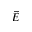Convert formula to latex. <formula><loc_0><loc_0><loc_500><loc_500>\vec { E }</formula> 